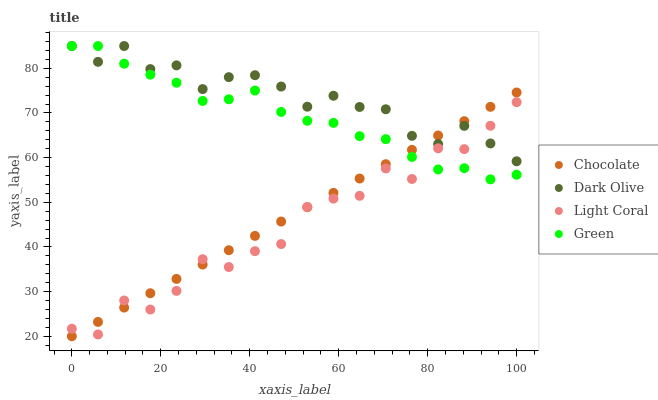Does Light Coral have the minimum area under the curve?
Answer yes or no. Yes. Does Dark Olive have the maximum area under the curve?
Answer yes or no. Yes. Does Green have the minimum area under the curve?
Answer yes or no. No. Does Green have the maximum area under the curve?
Answer yes or no. No. Is Chocolate the smoothest?
Answer yes or no. Yes. Is Light Coral the roughest?
Answer yes or no. Yes. Is Dark Olive the smoothest?
Answer yes or no. No. Is Dark Olive the roughest?
Answer yes or no. No. Does Chocolate have the lowest value?
Answer yes or no. Yes. Does Green have the lowest value?
Answer yes or no. No. Does Green have the highest value?
Answer yes or no. Yes. Does Chocolate have the highest value?
Answer yes or no. No. Does Green intersect Chocolate?
Answer yes or no. Yes. Is Green less than Chocolate?
Answer yes or no. No. Is Green greater than Chocolate?
Answer yes or no. No. 